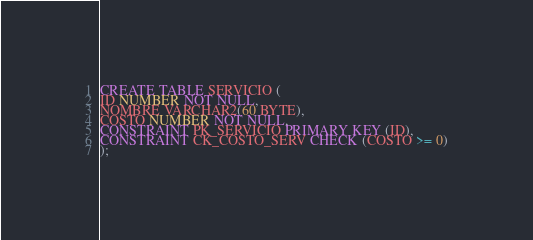<code> <loc_0><loc_0><loc_500><loc_500><_SQL_>CREATE TABLE SERVICIO (
ID NUMBER NOT NULL, 
NOMBRE VARCHAR2(60 BYTE),
COSTO NUMBER NOT NULL,
CONSTRAINT PK_SERVICIO PRIMARY KEY (ID), 
CONSTRAINT CK_COSTO_SERV CHECK (COSTO >= 0)
);</code> 